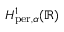<formula> <loc_0><loc_0><loc_500><loc_500>H _ { p e r , \alpha } ^ { 1 } ( \mathbb { R } )</formula> 